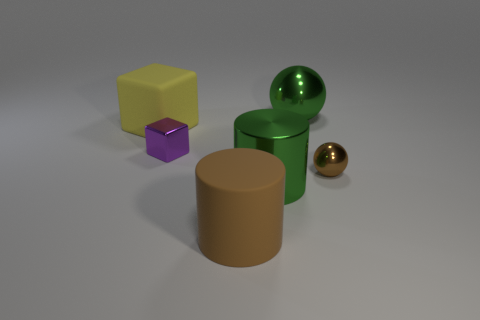Can you tell me the color and shape of the object to the left of the green sphere? Certainly! The object to the left of the green sphere is a yellow cube with its distinct six square faces. 